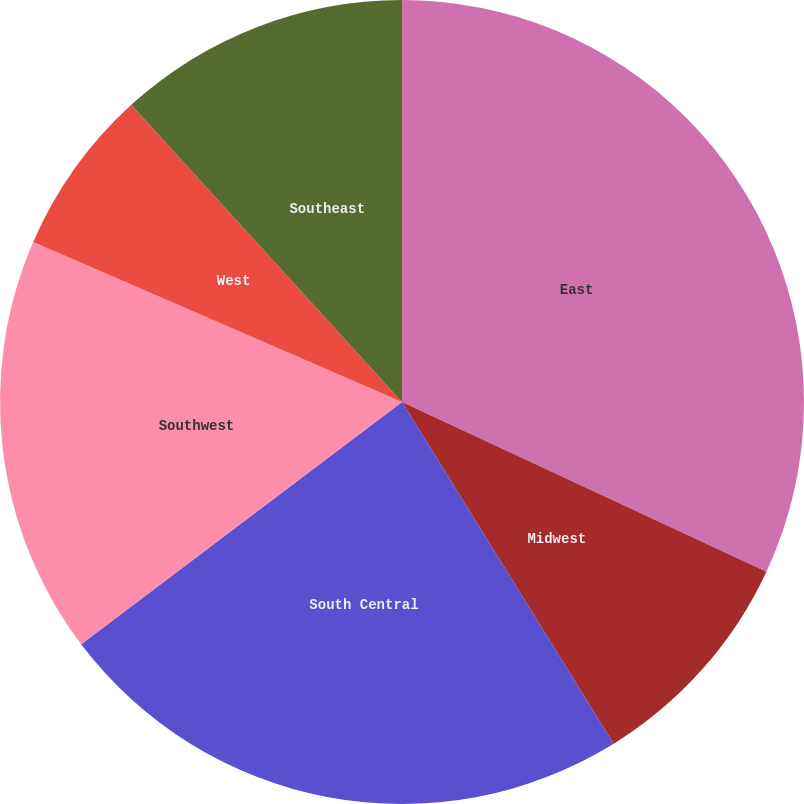<chart> <loc_0><loc_0><loc_500><loc_500><pie_chart><fcel>East<fcel>Midwest<fcel>South Central<fcel>Southwest<fcel>West<fcel>Southeast<nl><fcel>31.93%<fcel>9.24%<fcel>23.53%<fcel>16.81%<fcel>6.72%<fcel>11.76%<nl></chart> 